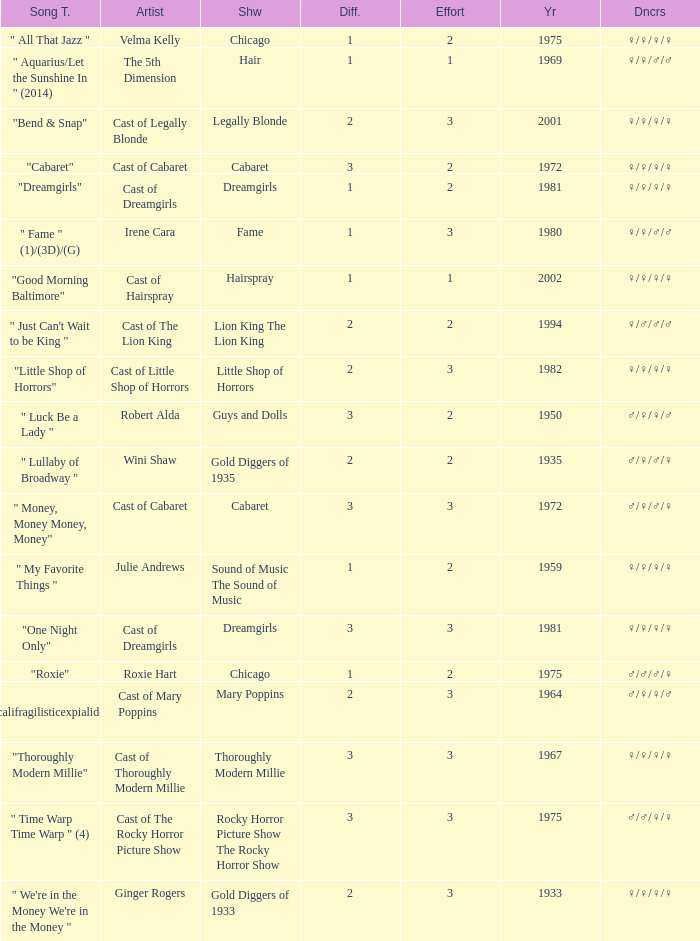How many artists were there for the show thoroughly modern millie? 1.0. 